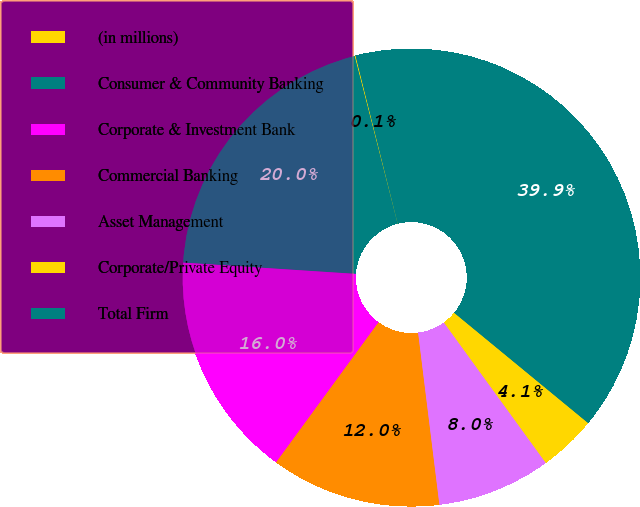Convert chart to OTSL. <chart><loc_0><loc_0><loc_500><loc_500><pie_chart><fcel>(in millions)<fcel>Consumer & Community Banking<fcel>Corporate & Investment Bank<fcel>Commercial Banking<fcel>Asset Management<fcel>Corporate/Private Equity<fcel>Total Firm<nl><fcel>0.07%<fcel>19.97%<fcel>15.99%<fcel>12.01%<fcel>8.03%<fcel>4.05%<fcel>39.88%<nl></chart> 